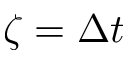Convert formula to latex. <formula><loc_0><loc_0><loc_500><loc_500>\zeta = \Delta t</formula> 